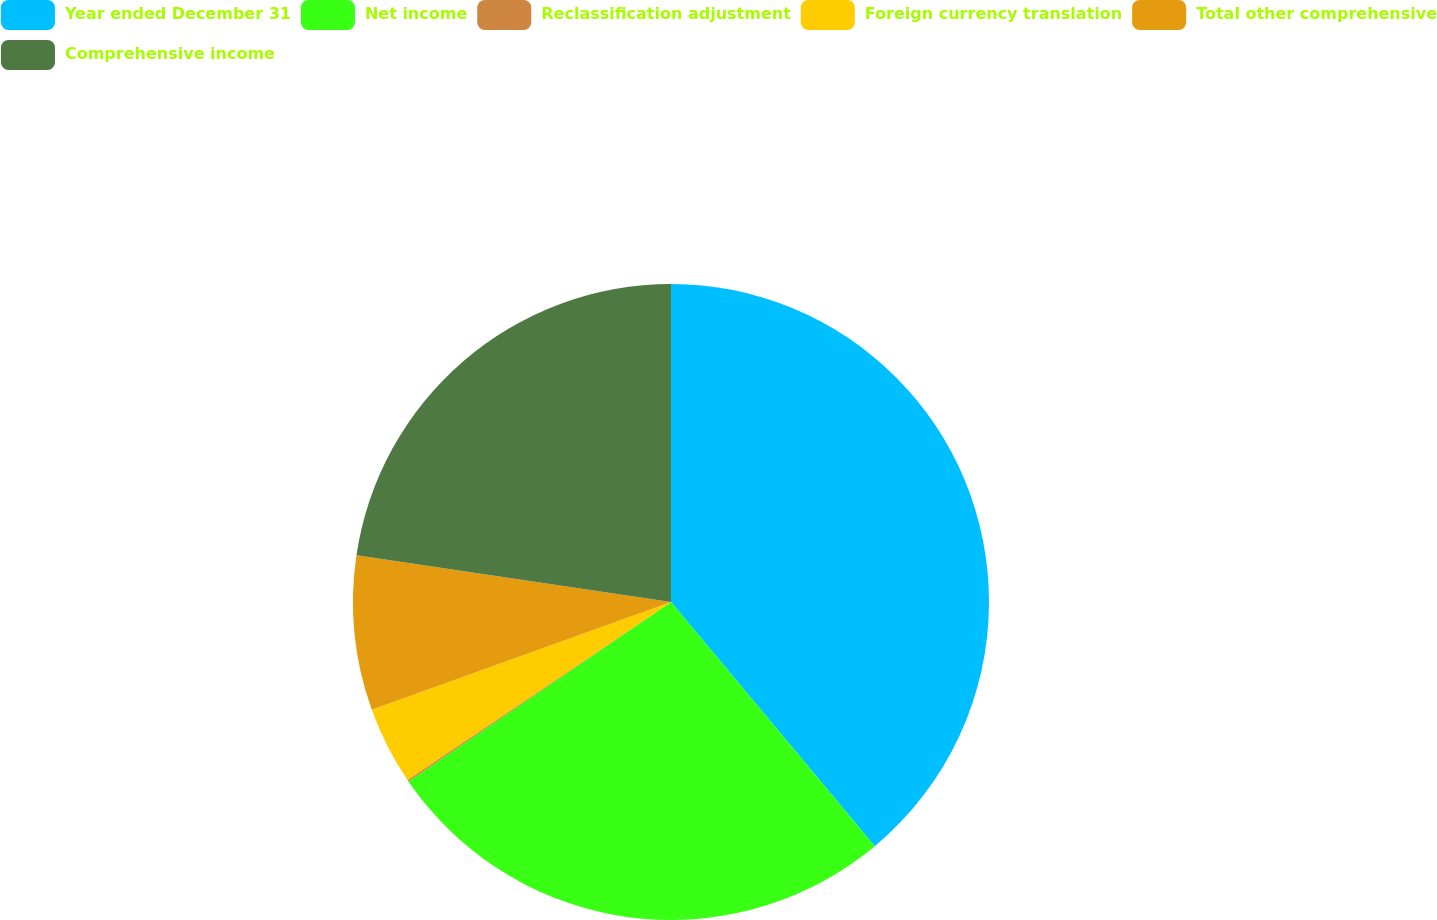Convert chart. <chart><loc_0><loc_0><loc_500><loc_500><pie_chart><fcel>Year ended December 31<fcel>Net income<fcel>Reclassification adjustment<fcel>Foreign currency translation<fcel>Total other comprehensive<fcel>Comprehensive income<nl><fcel>38.93%<fcel>26.53%<fcel>0.08%<fcel>3.96%<fcel>7.85%<fcel>22.65%<nl></chart> 